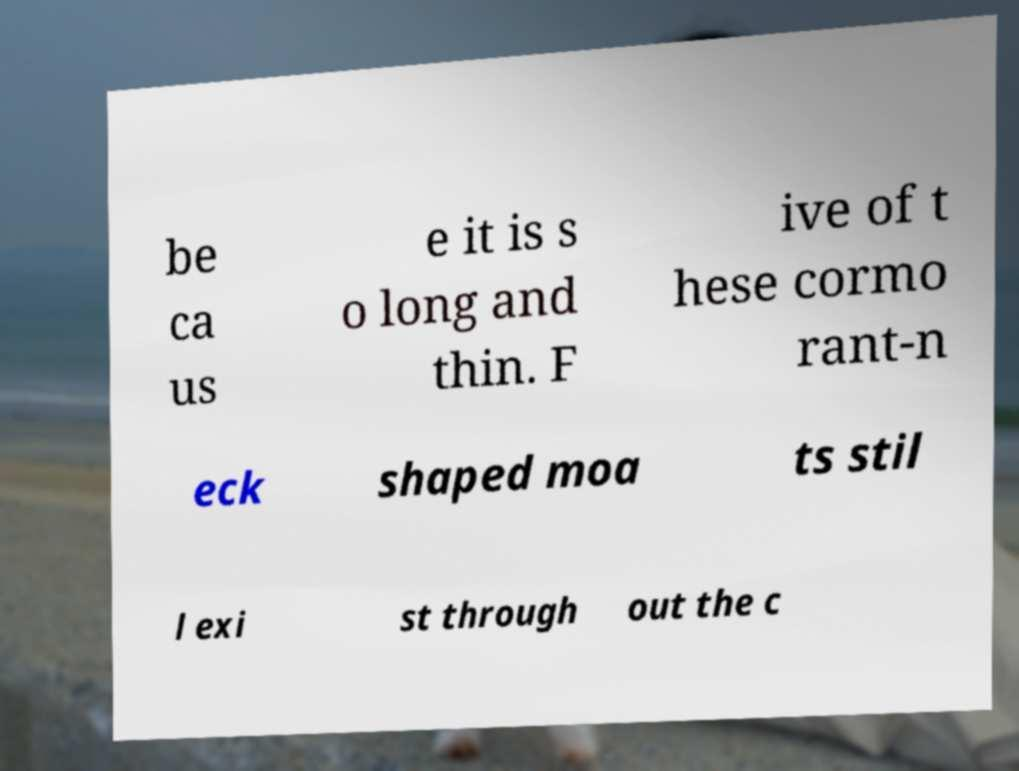What messages or text are displayed in this image? I need them in a readable, typed format. be ca us e it is s o long and thin. F ive of t hese cormo rant-n eck shaped moa ts stil l exi st through out the c 